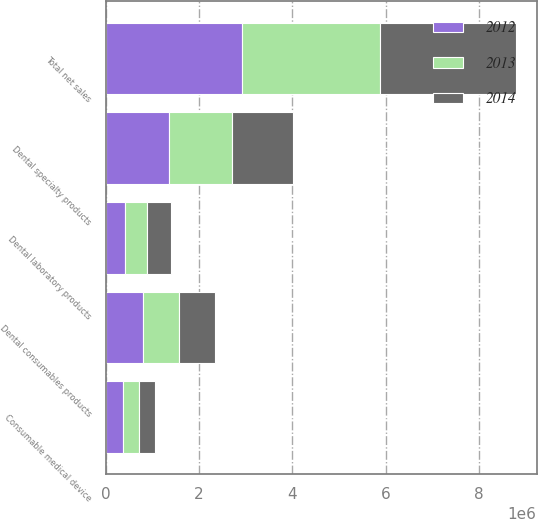Convert chart to OTSL. <chart><loc_0><loc_0><loc_500><loc_500><stacked_bar_chart><ecel><fcel>Dental consumables products<fcel>Dental laboratory products<fcel>Dental specialty products<fcel>Consumable medical device<fcel>Total net sales<nl><fcel>2012<fcel>787917<fcel>408981<fcel>1.3644e+06<fcel>361323<fcel>2.92262e+06<nl><fcel>2013<fcel>777935<fcel>472080<fcel>1.34742e+06<fcel>353338<fcel>2.95077e+06<nl><fcel>2014<fcel>768098<fcel>511850<fcel>1.31304e+06<fcel>335446<fcel>2.92843e+06<nl></chart> 